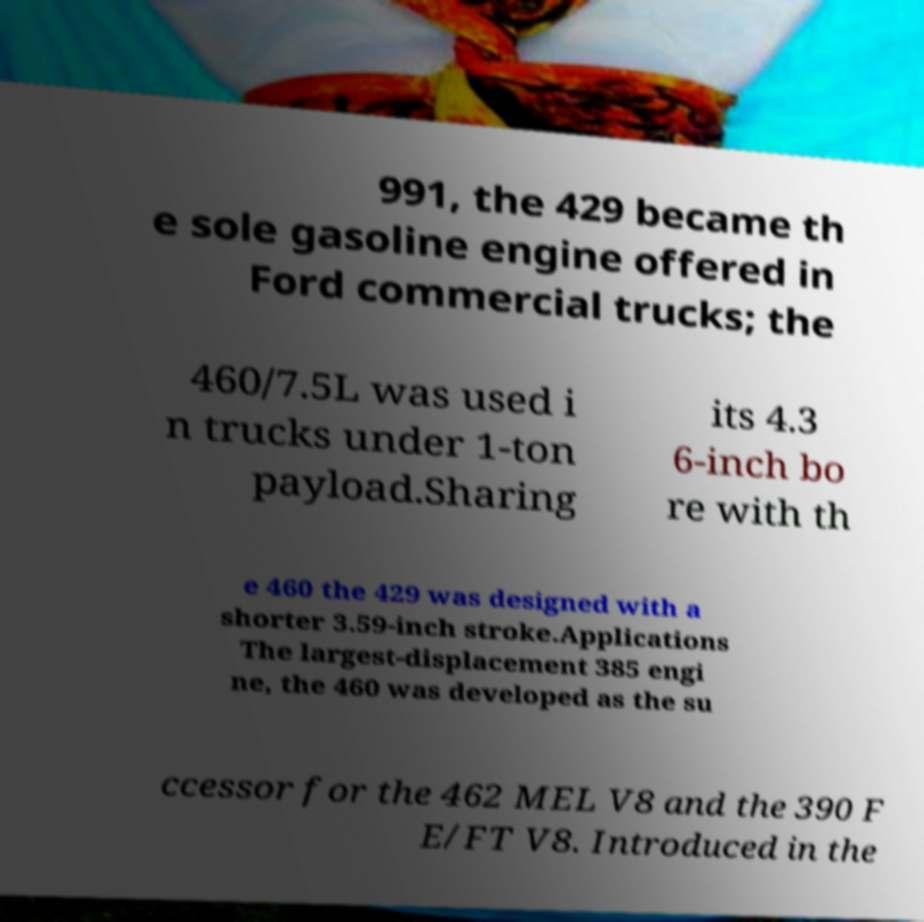Please read and relay the text visible in this image. What does it say? 991, the 429 became th e sole gasoline engine offered in Ford commercial trucks; the 460/7.5L was used i n trucks under 1-ton payload.Sharing its 4.3 6-inch bo re with th e 460 the 429 was designed with a shorter 3.59-inch stroke.Applications The largest-displacement 385 engi ne, the 460 was developed as the su ccessor for the 462 MEL V8 and the 390 F E/FT V8. Introduced in the 